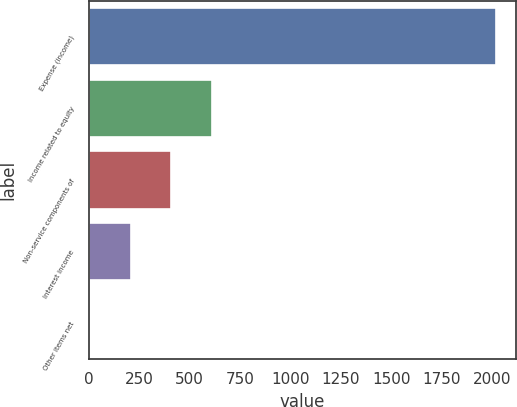Convert chart. <chart><loc_0><loc_0><loc_500><loc_500><bar_chart><fcel>Expense (income)<fcel>Income related to equity<fcel>Non-service components of<fcel>Interest income<fcel>Other items net<nl><fcel>2018<fcel>608.9<fcel>407.6<fcel>206.3<fcel>5<nl></chart> 